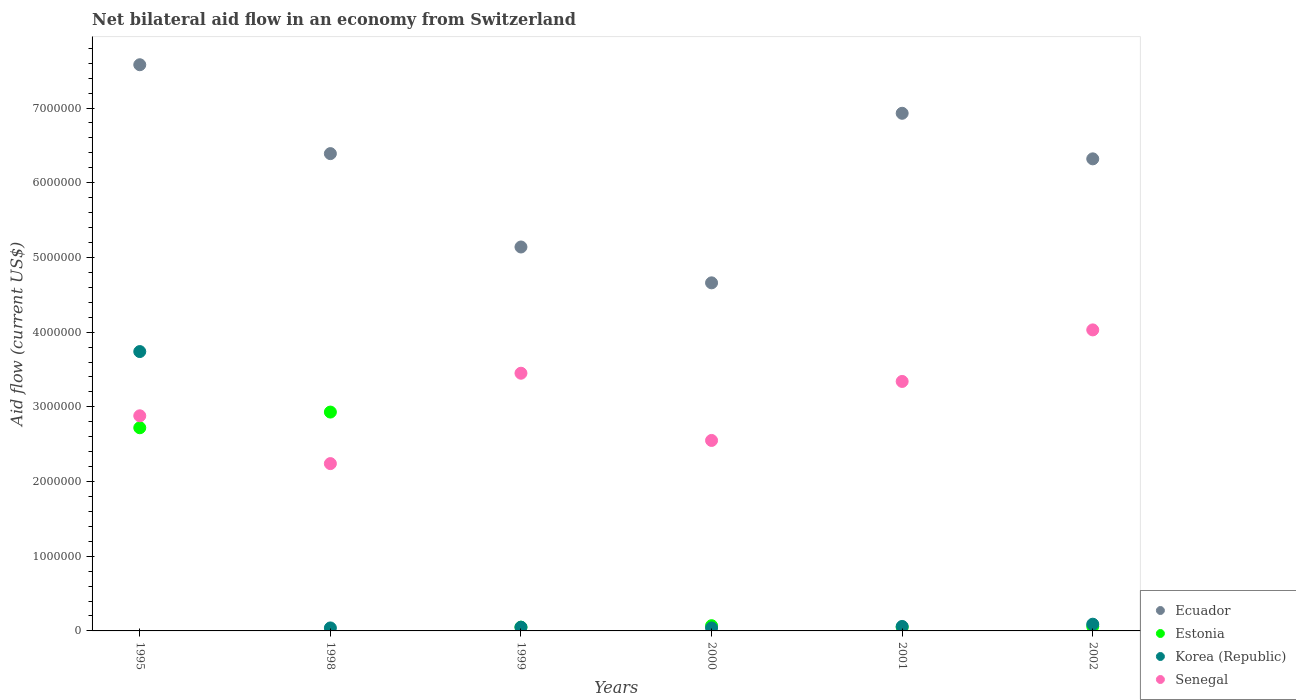How many different coloured dotlines are there?
Give a very brief answer. 4. Is the number of dotlines equal to the number of legend labels?
Offer a very short reply. Yes. What is the net bilateral aid flow in Korea (Republic) in 1995?
Your answer should be very brief. 3.74e+06. Across all years, what is the maximum net bilateral aid flow in Ecuador?
Provide a succinct answer. 7.58e+06. In which year was the net bilateral aid flow in Ecuador maximum?
Ensure brevity in your answer.  1995. What is the total net bilateral aid flow in Senegal in the graph?
Your response must be concise. 1.85e+07. What is the difference between the net bilateral aid flow in Ecuador in 1995 and that in 2002?
Offer a terse response. 1.26e+06. What is the difference between the net bilateral aid flow in Korea (Republic) in 1998 and the net bilateral aid flow in Senegal in 1995?
Keep it short and to the point. -2.84e+06. What is the average net bilateral aid flow in Estonia per year?
Your answer should be compact. 9.80e+05. In the year 1999, what is the difference between the net bilateral aid flow in Korea (Republic) and net bilateral aid flow in Ecuador?
Provide a succinct answer. -5.09e+06. In how many years, is the net bilateral aid flow in Estonia greater than 2600000 US$?
Your response must be concise. 2. What is the ratio of the net bilateral aid flow in Senegal in 1995 to that in 2000?
Make the answer very short. 1.13. Is the difference between the net bilateral aid flow in Korea (Republic) in 1995 and 2000 greater than the difference between the net bilateral aid flow in Ecuador in 1995 and 2000?
Offer a very short reply. Yes. What is the difference between the highest and the second highest net bilateral aid flow in Senegal?
Offer a terse response. 5.80e+05. What is the difference between the highest and the lowest net bilateral aid flow in Estonia?
Ensure brevity in your answer.  2.88e+06. In how many years, is the net bilateral aid flow in Korea (Republic) greater than the average net bilateral aid flow in Korea (Republic) taken over all years?
Your response must be concise. 1. Is the sum of the net bilateral aid flow in Estonia in 1995 and 2000 greater than the maximum net bilateral aid flow in Senegal across all years?
Keep it short and to the point. No. Does the net bilateral aid flow in Ecuador monotonically increase over the years?
Make the answer very short. No. Is the net bilateral aid flow in Senegal strictly greater than the net bilateral aid flow in Estonia over the years?
Provide a succinct answer. No. Is the net bilateral aid flow in Estonia strictly less than the net bilateral aid flow in Korea (Republic) over the years?
Your answer should be compact. No. How many years are there in the graph?
Ensure brevity in your answer.  6. Are the values on the major ticks of Y-axis written in scientific E-notation?
Your answer should be very brief. No. Does the graph contain any zero values?
Keep it short and to the point. No. How many legend labels are there?
Ensure brevity in your answer.  4. What is the title of the graph?
Your answer should be very brief. Net bilateral aid flow in an economy from Switzerland. What is the label or title of the Y-axis?
Keep it short and to the point. Aid flow (current US$). What is the Aid flow (current US$) of Ecuador in 1995?
Your answer should be compact. 7.58e+06. What is the Aid flow (current US$) in Estonia in 1995?
Your answer should be very brief. 2.72e+06. What is the Aid flow (current US$) in Korea (Republic) in 1995?
Your response must be concise. 3.74e+06. What is the Aid flow (current US$) in Senegal in 1995?
Your answer should be very brief. 2.88e+06. What is the Aid flow (current US$) of Ecuador in 1998?
Your response must be concise. 6.39e+06. What is the Aid flow (current US$) in Estonia in 1998?
Keep it short and to the point. 2.93e+06. What is the Aid flow (current US$) in Korea (Republic) in 1998?
Keep it short and to the point. 4.00e+04. What is the Aid flow (current US$) of Senegal in 1998?
Your response must be concise. 2.24e+06. What is the Aid flow (current US$) of Ecuador in 1999?
Your answer should be compact. 5.14e+06. What is the Aid flow (current US$) of Senegal in 1999?
Make the answer very short. 3.45e+06. What is the Aid flow (current US$) in Ecuador in 2000?
Keep it short and to the point. 4.66e+06. What is the Aid flow (current US$) of Korea (Republic) in 2000?
Your answer should be very brief. 4.00e+04. What is the Aid flow (current US$) of Senegal in 2000?
Offer a terse response. 2.55e+06. What is the Aid flow (current US$) in Ecuador in 2001?
Your answer should be compact. 6.93e+06. What is the Aid flow (current US$) in Estonia in 2001?
Offer a very short reply. 5.00e+04. What is the Aid flow (current US$) of Senegal in 2001?
Provide a short and direct response. 3.34e+06. What is the Aid flow (current US$) in Ecuador in 2002?
Provide a succinct answer. 6.32e+06. What is the Aid flow (current US$) in Estonia in 2002?
Offer a very short reply. 6.00e+04. What is the Aid flow (current US$) of Korea (Republic) in 2002?
Your answer should be compact. 9.00e+04. What is the Aid flow (current US$) in Senegal in 2002?
Offer a terse response. 4.03e+06. Across all years, what is the maximum Aid flow (current US$) in Ecuador?
Offer a terse response. 7.58e+06. Across all years, what is the maximum Aid flow (current US$) in Estonia?
Your response must be concise. 2.93e+06. Across all years, what is the maximum Aid flow (current US$) in Korea (Republic)?
Make the answer very short. 3.74e+06. Across all years, what is the maximum Aid flow (current US$) in Senegal?
Offer a very short reply. 4.03e+06. Across all years, what is the minimum Aid flow (current US$) of Ecuador?
Provide a succinct answer. 4.66e+06. Across all years, what is the minimum Aid flow (current US$) in Estonia?
Offer a terse response. 5.00e+04. Across all years, what is the minimum Aid flow (current US$) of Korea (Republic)?
Your answer should be very brief. 4.00e+04. Across all years, what is the minimum Aid flow (current US$) of Senegal?
Your answer should be compact. 2.24e+06. What is the total Aid flow (current US$) in Ecuador in the graph?
Provide a succinct answer. 3.70e+07. What is the total Aid flow (current US$) in Estonia in the graph?
Keep it short and to the point. 5.88e+06. What is the total Aid flow (current US$) of Korea (Republic) in the graph?
Your answer should be compact. 4.02e+06. What is the total Aid flow (current US$) in Senegal in the graph?
Ensure brevity in your answer.  1.85e+07. What is the difference between the Aid flow (current US$) in Ecuador in 1995 and that in 1998?
Offer a terse response. 1.19e+06. What is the difference between the Aid flow (current US$) of Estonia in 1995 and that in 1998?
Your answer should be very brief. -2.10e+05. What is the difference between the Aid flow (current US$) of Korea (Republic) in 1995 and that in 1998?
Provide a succinct answer. 3.70e+06. What is the difference between the Aid flow (current US$) of Senegal in 1995 and that in 1998?
Offer a very short reply. 6.40e+05. What is the difference between the Aid flow (current US$) of Ecuador in 1995 and that in 1999?
Offer a terse response. 2.44e+06. What is the difference between the Aid flow (current US$) in Estonia in 1995 and that in 1999?
Your answer should be compact. 2.67e+06. What is the difference between the Aid flow (current US$) of Korea (Republic) in 1995 and that in 1999?
Offer a very short reply. 3.69e+06. What is the difference between the Aid flow (current US$) in Senegal in 1995 and that in 1999?
Offer a terse response. -5.70e+05. What is the difference between the Aid flow (current US$) in Ecuador in 1995 and that in 2000?
Give a very brief answer. 2.92e+06. What is the difference between the Aid flow (current US$) in Estonia in 1995 and that in 2000?
Provide a succinct answer. 2.65e+06. What is the difference between the Aid flow (current US$) in Korea (Republic) in 1995 and that in 2000?
Keep it short and to the point. 3.70e+06. What is the difference between the Aid flow (current US$) in Senegal in 1995 and that in 2000?
Your response must be concise. 3.30e+05. What is the difference between the Aid flow (current US$) of Ecuador in 1995 and that in 2001?
Your answer should be compact. 6.50e+05. What is the difference between the Aid flow (current US$) of Estonia in 1995 and that in 2001?
Your answer should be compact. 2.67e+06. What is the difference between the Aid flow (current US$) of Korea (Republic) in 1995 and that in 2001?
Your answer should be very brief. 3.68e+06. What is the difference between the Aid flow (current US$) in Senegal in 1995 and that in 2001?
Your answer should be compact. -4.60e+05. What is the difference between the Aid flow (current US$) of Ecuador in 1995 and that in 2002?
Keep it short and to the point. 1.26e+06. What is the difference between the Aid flow (current US$) in Estonia in 1995 and that in 2002?
Ensure brevity in your answer.  2.66e+06. What is the difference between the Aid flow (current US$) in Korea (Republic) in 1995 and that in 2002?
Ensure brevity in your answer.  3.65e+06. What is the difference between the Aid flow (current US$) in Senegal in 1995 and that in 2002?
Offer a very short reply. -1.15e+06. What is the difference between the Aid flow (current US$) of Ecuador in 1998 and that in 1999?
Offer a terse response. 1.25e+06. What is the difference between the Aid flow (current US$) in Estonia in 1998 and that in 1999?
Provide a succinct answer. 2.88e+06. What is the difference between the Aid flow (current US$) in Senegal in 1998 and that in 1999?
Offer a very short reply. -1.21e+06. What is the difference between the Aid flow (current US$) in Ecuador in 1998 and that in 2000?
Make the answer very short. 1.73e+06. What is the difference between the Aid flow (current US$) of Estonia in 1998 and that in 2000?
Your response must be concise. 2.86e+06. What is the difference between the Aid flow (current US$) of Senegal in 1998 and that in 2000?
Offer a very short reply. -3.10e+05. What is the difference between the Aid flow (current US$) of Ecuador in 1998 and that in 2001?
Your response must be concise. -5.40e+05. What is the difference between the Aid flow (current US$) of Estonia in 1998 and that in 2001?
Offer a terse response. 2.88e+06. What is the difference between the Aid flow (current US$) in Senegal in 1998 and that in 2001?
Offer a terse response. -1.10e+06. What is the difference between the Aid flow (current US$) in Estonia in 1998 and that in 2002?
Offer a terse response. 2.87e+06. What is the difference between the Aid flow (current US$) in Korea (Republic) in 1998 and that in 2002?
Make the answer very short. -5.00e+04. What is the difference between the Aid flow (current US$) of Senegal in 1998 and that in 2002?
Give a very brief answer. -1.79e+06. What is the difference between the Aid flow (current US$) in Ecuador in 1999 and that in 2000?
Make the answer very short. 4.80e+05. What is the difference between the Aid flow (current US$) in Estonia in 1999 and that in 2000?
Keep it short and to the point. -2.00e+04. What is the difference between the Aid flow (current US$) of Senegal in 1999 and that in 2000?
Make the answer very short. 9.00e+05. What is the difference between the Aid flow (current US$) in Ecuador in 1999 and that in 2001?
Make the answer very short. -1.79e+06. What is the difference between the Aid flow (current US$) of Korea (Republic) in 1999 and that in 2001?
Your response must be concise. -10000. What is the difference between the Aid flow (current US$) in Ecuador in 1999 and that in 2002?
Offer a very short reply. -1.18e+06. What is the difference between the Aid flow (current US$) in Senegal in 1999 and that in 2002?
Your answer should be very brief. -5.80e+05. What is the difference between the Aid flow (current US$) in Ecuador in 2000 and that in 2001?
Offer a terse response. -2.27e+06. What is the difference between the Aid flow (current US$) in Korea (Republic) in 2000 and that in 2001?
Provide a succinct answer. -2.00e+04. What is the difference between the Aid flow (current US$) of Senegal in 2000 and that in 2001?
Offer a very short reply. -7.90e+05. What is the difference between the Aid flow (current US$) in Ecuador in 2000 and that in 2002?
Provide a short and direct response. -1.66e+06. What is the difference between the Aid flow (current US$) of Senegal in 2000 and that in 2002?
Your response must be concise. -1.48e+06. What is the difference between the Aid flow (current US$) of Ecuador in 2001 and that in 2002?
Ensure brevity in your answer.  6.10e+05. What is the difference between the Aid flow (current US$) in Estonia in 2001 and that in 2002?
Offer a terse response. -10000. What is the difference between the Aid flow (current US$) in Senegal in 2001 and that in 2002?
Your answer should be compact. -6.90e+05. What is the difference between the Aid flow (current US$) in Ecuador in 1995 and the Aid flow (current US$) in Estonia in 1998?
Your response must be concise. 4.65e+06. What is the difference between the Aid flow (current US$) of Ecuador in 1995 and the Aid flow (current US$) of Korea (Republic) in 1998?
Provide a succinct answer. 7.54e+06. What is the difference between the Aid flow (current US$) of Ecuador in 1995 and the Aid flow (current US$) of Senegal in 1998?
Provide a succinct answer. 5.34e+06. What is the difference between the Aid flow (current US$) in Estonia in 1995 and the Aid flow (current US$) in Korea (Republic) in 1998?
Provide a short and direct response. 2.68e+06. What is the difference between the Aid flow (current US$) in Estonia in 1995 and the Aid flow (current US$) in Senegal in 1998?
Provide a succinct answer. 4.80e+05. What is the difference between the Aid flow (current US$) of Korea (Republic) in 1995 and the Aid flow (current US$) of Senegal in 1998?
Your answer should be compact. 1.50e+06. What is the difference between the Aid flow (current US$) of Ecuador in 1995 and the Aid flow (current US$) of Estonia in 1999?
Provide a short and direct response. 7.53e+06. What is the difference between the Aid flow (current US$) in Ecuador in 1995 and the Aid flow (current US$) in Korea (Republic) in 1999?
Your answer should be very brief. 7.53e+06. What is the difference between the Aid flow (current US$) of Ecuador in 1995 and the Aid flow (current US$) of Senegal in 1999?
Offer a terse response. 4.13e+06. What is the difference between the Aid flow (current US$) of Estonia in 1995 and the Aid flow (current US$) of Korea (Republic) in 1999?
Your answer should be very brief. 2.67e+06. What is the difference between the Aid flow (current US$) of Estonia in 1995 and the Aid flow (current US$) of Senegal in 1999?
Offer a terse response. -7.30e+05. What is the difference between the Aid flow (current US$) of Korea (Republic) in 1995 and the Aid flow (current US$) of Senegal in 1999?
Provide a short and direct response. 2.90e+05. What is the difference between the Aid flow (current US$) of Ecuador in 1995 and the Aid flow (current US$) of Estonia in 2000?
Make the answer very short. 7.51e+06. What is the difference between the Aid flow (current US$) of Ecuador in 1995 and the Aid flow (current US$) of Korea (Republic) in 2000?
Ensure brevity in your answer.  7.54e+06. What is the difference between the Aid flow (current US$) in Ecuador in 1995 and the Aid flow (current US$) in Senegal in 2000?
Make the answer very short. 5.03e+06. What is the difference between the Aid flow (current US$) in Estonia in 1995 and the Aid flow (current US$) in Korea (Republic) in 2000?
Provide a succinct answer. 2.68e+06. What is the difference between the Aid flow (current US$) in Estonia in 1995 and the Aid flow (current US$) in Senegal in 2000?
Make the answer very short. 1.70e+05. What is the difference between the Aid flow (current US$) of Korea (Republic) in 1995 and the Aid flow (current US$) of Senegal in 2000?
Make the answer very short. 1.19e+06. What is the difference between the Aid flow (current US$) of Ecuador in 1995 and the Aid flow (current US$) of Estonia in 2001?
Provide a short and direct response. 7.53e+06. What is the difference between the Aid flow (current US$) in Ecuador in 1995 and the Aid flow (current US$) in Korea (Republic) in 2001?
Your answer should be very brief. 7.52e+06. What is the difference between the Aid flow (current US$) in Ecuador in 1995 and the Aid flow (current US$) in Senegal in 2001?
Keep it short and to the point. 4.24e+06. What is the difference between the Aid flow (current US$) of Estonia in 1995 and the Aid flow (current US$) of Korea (Republic) in 2001?
Your response must be concise. 2.66e+06. What is the difference between the Aid flow (current US$) in Estonia in 1995 and the Aid flow (current US$) in Senegal in 2001?
Your response must be concise. -6.20e+05. What is the difference between the Aid flow (current US$) in Ecuador in 1995 and the Aid flow (current US$) in Estonia in 2002?
Keep it short and to the point. 7.52e+06. What is the difference between the Aid flow (current US$) in Ecuador in 1995 and the Aid flow (current US$) in Korea (Republic) in 2002?
Offer a very short reply. 7.49e+06. What is the difference between the Aid flow (current US$) in Ecuador in 1995 and the Aid flow (current US$) in Senegal in 2002?
Your answer should be very brief. 3.55e+06. What is the difference between the Aid flow (current US$) in Estonia in 1995 and the Aid flow (current US$) in Korea (Republic) in 2002?
Your answer should be very brief. 2.63e+06. What is the difference between the Aid flow (current US$) in Estonia in 1995 and the Aid flow (current US$) in Senegal in 2002?
Offer a very short reply. -1.31e+06. What is the difference between the Aid flow (current US$) of Korea (Republic) in 1995 and the Aid flow (current US$) of Senegal in 2002?
Your answer should be compact. -2.90e+05. What is the difference between the Aid flow (current US$) of Ecuador in 1998 and the Aid flow (current US$) of Estonia in 1999?
Keep it short and to the point. 6.34e+06. What is the difference between the Aid flow (current US$) in Ecuador in 1998 and the Aid flow (current US$) in Korea (Republic) in 1999?
Provide a succinct answer. 6.34e+06. What is the difference between the Aid flow (current US$) in Ecuador in 1998 and the Aid flow (current US$) in Senegal in 1999?
Give a very brief answer. 2.94e+06. What is the difference between the Aid flow (current US$) of Estonia in 1998 and the Aid flow (current US$) of Korea (Republic) in 1999?
Ensure brevity in your answer.  2.88e+06. What is the difference between the Aid flow (current US$) in Estonia in 1998 and the Aid flow (current US$) in Senegal in 1999?
Your answer should be very brief. -5.20e+05. What is the difference between the Aid flow (current US$) in Korea (Republic) in 1998 and the Aid flow (current US$) in Senegal in 1999?
Your response must be concise. -3.41e+06. What is the difference between the Aid flow (current US$) in Ecuador in 1998 and the Aid flow (current US$) in Estonia in 2000?
Offer a terse response. 6.32e+06. What is the difference between the Aid flow (current US$) of Ecuador in 1998 and the Aid flow (current US$) of Korea (Republic) in 2000?
Your response must be concise. 6.35e+06. What is the difference between the Aid flow (current US$) in Ecuador in 1998 and the Aid flow (current US$) in Senegal in 2000?
Keep it short and to the point. 3.84e+06. What is the difference between the Aid flow (current US$) of Estonia in 1998 and the Aid flow (current US$) of Korea (Republic) in 2000?
Your response must be concise. 2.89e+06. What is the difference between the Aid flow (current US$) of Korea (Republic) in 1998 and the Aid flow (current US$) of Senegal in 2000?
Offer a terse response. -2.51e+06. What is the difference between the Aid flow (current US$) in Ecuador in 1998 and the Aid flow (current US$) in Estonia in 2001?
Offer a terse response. 6.34e+06. What is the difference between the Aid flow (current US$) in Ecuador in 1998 and the Aid flow (current US$) in Korea (Republic) in 2001?
Offer a very short reply. 6.33e+06. What is the difference between the Aid flow (current US$) of Ecuador in 1998 and the Aid flow (current US$) of Senegal in 2001?
Your answer should be very brief. 3.05e+06. What is the difference between the Aid flow (current US$) in Estonia in 1998 and the Aid flow (current US$) in Korea (Republic) in 2001?
Offer a terse response. 2.87e+06. What is the difference between the Aid flow (current US$) of Estonia in 1998 and the Aid flow (current US$) of Senegal in 2001?
Ensure brevity in your answer.  -4.10e+05. What is the difference between the Aid flow (current US$) of Korea (Republic) in 1998 and the Aid flow (current US$) of Senegal in 2001?
Your answer should be compact. -3.30e+06. What is the difference between the Aid flow (current US$) in Ecuador in 1998 and the Aid flow (current US$) in Estonia in 2002?
Your response must be concise. 6.33e+06. What is the difference between the Aid flow (current US$) in Ecuador in 1998 and the Aid flow (current US$) in Korea (Republic) in 2002?
Ensure brevity in your answer.  6.30e+06. What is the difference between the Aid flow (current US$) of Ecuador in 1998 and the Aid flow (current US$) of Senegal in 2002?
Provide a short and direct response. 2.36e+06. What is the difference between the Aid flow (current US$) of Estonia in 1998 and the Aid flow (current US$) of Korea (Republic) in 2002?
Give a very brief answer. 2.84e+06. What is the difference between the Aid flow (current US$) in Estonia in 1998 and the Aid flow (current US$) in Senegal in 2002?
Your answer should be compact. -1.10e+06. What is the difference between the Aid flow (current US$) in Korea (Republic) in 1998 and the Aid flow (current US$) in Senegal in 2002?
Offer a terse response. -3.99e+06. What is the difference between the Aid flow (current US$) of Ecuador in 1999 and the Aid flow (current US$) of Estonia in 2000?
Give a very brief answer. 5.07e+06. What is the difference between the Aid flow (current US$) in Ecuador in 1999 and the Aid flow (current US$) in Korea (Republic) in 2000?
Offer a very short reply. 5.10e+06. What is the difference between the Aid flow (current US$) of Ecuador in 1999 and the Aid flow (current US$) of Senegal in 2000?
Your response must be concise. 2.59e+06. What is the difference between the Aid flow (current US$) of Estonia in 1999 and the Aid flow (current US$) of Senegal in 2000?
Your response must be concise. -2.50e+06. What is the difference between the Aid flow (current US$) in Korea (Republic) in 1999 and the Aid flow (current US$) in Senegal in 2000?
Keep it short and to the point. -2.50e+06. What is the difference between the Aid flow (current US$) of Ecuador in 1999 and the Aid flow (current US$) of Estonia in 2001?
Offer a terse response. 5.09e+06. What is the difference between the Aid flow (current US$) in Ecuador in 1999 and the Aid flow (current US$) in Korea (Republic) in 2001?
Provide a succinct answer. 5.08e+06. What is the difference between the Aid flow (current US$) of Ecuador in 1999 and the Aid flow (current US$) of Senegal in 2001?
Your answer should be compact. 1.80e+06. What is the difference between the Aid flow (current US$) of Estonia in 1999 and the Aid flow (current US$) of Senegal in 2001?
Your answer should be very brief. -3.29e+06. What is the difference between the Aid flow (current US$) in Korea (Republic) in 1999 and the Aid flow (current US$) in Senegal in 2001?
Provide a short and direct response. -3.29e+06. What is the difference between the Aid flow (current US$) in Ecuador in 1999 and the Aid flow (current US$) in Estonia in 2002?
Your response must be concise. 5.08e+06. What is the difference between the Aid flow (current US$) in Ecuador in 1999 and the Aid flow (current US$) in Korea (Republic) in 2002?
Make the answer very short. 5.05e+06. What is the difference between the Aid flow (current US$) of Ecuador in 1999 and the Aid flow (current US$) of Senegal in 2002?
Provide a succinct answer. 1.11e+06. What is the difference between the Aid flow (current US$) in Estonia in 1999 and the Aid flow (current US$) in Senegal in 2002?
Provide a succinct answer. -3.98e+06. What is the difference between the Aid flow (current US$) of Korea (Republic) in 1999 and the Aid flow (current US$) of Senegal in 2002?
Provide a succinct answer. -3.98e+06. What is the difference between the Aid flow (current US$) of Ecuador in 2000 and the Aid flow (current US$) of Estonia in 2001?
Keep it short and to the point. 4.61e+06. What is the difference between the Aid flow (current US$) in Ecuador in 2000 and the Aid flow (current US$) in Korea (Republic) in 2001?
Give a very brief answer. 4.60e+06. What is the difference between the Aid flow (current US$) of Ecuador in 2000 and the Aid flow (current US$) of Senegal in 2001?
Provide a succinct answer. 1.32e+06. What is the difference between the Aid flow (current US$) in Estonia in 2000 and the Aid flow (current US$) in Senegal in 2001?
Your response must be concise. -3.27e+06. What is the difference between the Aid flow (current US$) in Korea (Republic) in 2000 and the Aid flow (current US$) in Senegal in 2001?
Keep it short and to the point. -3.30e+06. What is the difference between the Aid flow (current US$) of Ecuador in 2000 and the Aid flow (current US$) of Estonia in 2002?
Make the answer very short. 4.60e+06. What is the difference between the Aid flow (current US$) in Ecuador in 2000 and the Aid flow (current US$) in Korea (Republic) in 2002?
Provide a succinct answer. 4.57e+06. What is the difference between the Aid flow (current US$) of Ecuador in 2000 and the Aid flow (current US$) of Senegal in 2002?
Ensure brevity in your answer.  6.30e+05. What is the difference between the Aid flow (current US$) of Estonia in 2000 and the Aid flow (current US$) of Senegal in 2002?
Your answer should be compact. -3.96e+06. What is the difference between the Aid flow (current US$) of Korea (Republic) in 2000 and the Aid flow (current US$) of Senegal in 2002?
Make the answer very short. -3.99e+06. What is the difference between the Aid flow (current US$) of Ecuador in 2001 and the Aid flow (current US$) of Estonia in 2002?
Provide a short and direct response. 6.87e+06. What is the difference between the Aid flow (current US$) in Ecuador in 2001 and the Aid flow (current US$) in Korea (Republic) in 2002?
Keep it short and to the point. 6.84e+06. What is the difference between the Aid flow (current US$) in Ecuador in 2001 and the Aid flow (current US$) in Senegal in 2002?
Your response must be concise. 2.90e+06. What is the difference between the Aid flow (current US$) of Estonia in 2001 and the Aid flow (current US$) of Senegal in 2002?
Your answer should be very brief. -3.98e+06. What is the difference between the Aid flow (current US$) in Korea (Republic) in 2001 and the Aid flow (current US$) in Senegal in 2002?
Your answer should be compact. -3.97e+06. What is the average Aid flow (current US$) in Ecuador per year?
Provide a short and direct response. 6.17e+06. What is the average Aid flow (current US$) of Estonia per year?
Your response must be concise. 9.80e+05. What is the average Aid flow (current US$) of Korea (Republic) per year?
Keep it short and to the point. 6.70e+05. What is the average Aid flow (current US$) of Senegal per year?
Offer a terse response. 3.08e+06. In the year 1995, what is the difference between the Aid flow (current US$) of Ecuador and Aid flow (current US$) of Estonia?
Keep it short and to the point. 4.86e+06. In the year 1995, what is the difference between the Aid flow (current US$) in Ecuador and Aid flow (current US$) in Korea (Republic)?
Offer a terse response. 3.84e+06. In the year 1995, what is the difference between the Aid flow (current US$) of Ecuador and Aid flow (current US$) of Senegal?
Provide a short and direct response. 4.70e+06. In the year 1995, what is the difference between the Aid flow (current US$) of Estonia and Aid flow (current US$) of Korea (Republic)?
Keep it short and to the point. -1.02e+06. In the year 1995, what is the difference between the Aid flow (current US$) in Estonia and Aid flow (current US$) in Senegal?
Give a very brief answer. -1.60e+05. In the year 1995, what is the difference between the Aid flow (current US$) in Korea (Republic) and Aid flow (current US$) in Senegal?
Your answer should be very brief. 8.60e+05. In the year 1998, what is the difference between the Aid flow (current US$) in Ecuador and Aid flow (current US$) in Estonia?
Provide a succinct answer. 3.46e+06. In the year 1998, what is the difference between the Aid flow (current US$) of Ecuador and Aid flow (current US$) of Korea (Republic)?
Keep it short and to the point. 6.35e+06. In the year 1998, what is the difference between the Aid flow (current US$) of Ecuador and Aid flow (current US$) of Senegal?
Offer a very short reply. 4.15e+06. In the year 1998, what is the difference between the Aid flow (current US$) of Estonia and Aid flow (current US$) of Korea (Republic)?
Your response must be concise. 2.89e+06. In the year 1998, what is the difference between the Aid flow (current US$) in Estonia and Aid flow (current US$) in Senegal?
Give a very brief answer. 6.90e+05. In the year 1998, what is the difference between the Aid flow (current US$) of Korea (Republic) and Aid flow (current US$) of Senegal?
Offer a terse response. -2.20e+06. In the year 1999, what is the difference between the Aid flow (current US$) in Ecuador and Aid flow (current US$) in Estonia?
Offer a very short reply. 5.09e+06. In the year 1999, what is the difference between the Aid flow (current US$) in Ecuador and Aid flow (current US$) in Korea (Republic)?
Your response must be concise. 5.09e+06. In the year 1999, what is the difference between the Aid flow (current US$) in Ecuador and Aid flow (current US$) in Senegal?
Your response must be concise. 1.69e+06. In the year 1999, what is the difference between the Aid flow (current US$) of Estonia and Aid flow (current US$) of Senegal?
Your answer should be compact. -3.40e+06. In the year 1999, what is the difference between the Aid flow (current US$) in Korea (Republic) and Aid flow (current US$) in Senegal?
Give a very brief answer. -3.40e+06. In the year 2000, what is the difference between the Aid flow (current US$) in Ecuador and Aid flow (current US$) in Estonia?
Provide a short and direct response. 4.59e+06. In the year 2000, what is the difference between the Aid flow (current US$) in Ecuador and Aid flow (current US$) in Korea (Republic)?
Provide a succinct answer. 4.62e+06. In the year 2000, what is the difference between the Aid flow (current US$) in Ecuador and Aid flow (current US$) in Senegal?
Your answer should be compact. 2.11e+06. In the year 2000, what is the difference between the Aid flow (current US$) of Estonia and Aid flow (current US$) of Senegal?
Offer a terse response. -2.48e+06. In the year 2000, what is the difference between the Aid flow (current US$) in Korea (Republic) and Aid flow (current US$) in Senegal?
Make the answer very short. -2.51e+06. In the year 2001, what is the difference between the Aid flow (current US$) in Ecuador and Aid flow (current US$) in Estonia?
Keep it short and to the point. 6.88e+06. In the year 2001, what is the difference between the Aid flow (current US$) of Ecuador and Aid flow (current US$) of Korea (Republic)?
Your response must be concise. 6.87e+06. In the year 2001, what is the difference between the Aid flow (current US$) of Ecuador and Aid flow (current US$) of Senegal?
Keep it short and to the point. 3.59e+06. In the year 2001, what is the difference between the Aid flow (current US$) of Estonia and Aid flow (current US$) of Korea (Republic)?
Your answer should be very brief. -10000. In the year 2001, what is the difference between the Aid flow (current US$) in Estonia and Aid flow (current US$) in Senegal?
Give a very brief answer. -3.29e+06. In the year 2001, what is the difference between the Aid flow (current US$) in Korea (Republic) and Aid flow (current US$) in Senegal?
Keep it short and to the point. -3.28e+06. In the year 2002, what is the difference between the Aid flow (current US$) of Ecuador and Aid flow (current US$) of Estonia?
Your answer should be very brief. 6.26e+06. In the year 2002, what is the difference between the Aid flow (current US$) in Ecuador and Aid flow (current US$) in Korea (Republic)?
Offer a very short reply. 6.23e+06. In the year 2002, what is the difference between the Aid flow (current US$) in Ecuador and Aid flow (current US$) in Senegal?
Make the answer very short. 2.29e+06. In the year 2002, what is the difference between the Aid flow (current US$) of Estonia and Aid flow (current US$) of Korea (Republic)?
Offer a very short reply. -3.00e+04. In the year 2002, what is the difference between the Aid flow (current US$) of Estonia and Aid flow (current US$) of Senegal?
Your answer should be compact. -3.97e+06. In the year 2002, what is the difference between the Aid flow (current US$) in Korea (Republic) and Aid flow (current US$) in Senegal?
Provide a short and direct response. -3.94e+06. What is the ratio of the Aid flow (current US$) in Ecuador in 1995 to that in 1998?
Keep it short and to the point. 1.19. What is the ratio of the Aid flow (current US$) in Estonia in 1995 to that in 1998?
Offer a terse response. 0.93. What is the ratio of the Aid flow (current US$) in Korea (Republic) in 1995 to that in 1998?
Your answer should be very brief. 93.5. What is the ratio of the Aid flow (current US$) in Ecuador in 1995 to that in 1999?
Keep it short and to the point. 1.47. What is the ratio of the Aid flow (current US$) in Estonia in 1995 to that in 1999?
Keep it short and to the point. 54.4. What is the ratio of the Aid flow (current US$) in Korea (Republic) in 1995 to that in 1999?
Keep it short and to the point. 74.8. What is the ratio of the Aid flow (current US$) in Senegal in 1995 to that in 1999?
Your response must be concise. 0.83. What is the ratio of the Aid flow (current US$) of Ecuador in 1995 to that in 2000?
Make the answer very short. 1.63. What is the ratio of the Aid flow (current US$) in Estonia in 1995 to that in 2000?
Make the answer very short. 38.86. What is the ratio of the Aid flow (current US$) of Korea (Republic) in 1995 to that in 2000?
Keep it short and to the point. 93.5. What is the ratio of the Aid flow (current US$) of Senegal in 1995 to that in 2000?
Offer a very short reply. 1.13. What is the ratio of the Aid flow (current US$) in Ecuador in 1995 to that in 2001?
Ensure brevity in your answer.  1.09. What is the ratio of the Aid flow (current US$) of Estonia in 1995 to that in 2001?
Make the answer very short. 54.4. What is the ratio of the Aid flow (current US$) of Korea (Republic) in 1995 to that in 2001?
Provide a succinct answer. 62.33. What is the ratio of the Aid flow (current US$) of Senegal in 1995 to that in 2001?
Ensure brevity in your answer.  0.86. What is the ratio of the Aid flow (current US$) in Ecuador in 1995 to that in 2002?
Keep it short and to the point. 1.2. What is the ratio of the Aid flow (current US$) of Estonia in 1995 to that in 2002?
Offer a terse response. 45.33. What is the ratio of the Aid flow (current US$) of Korea (Republic) in 1995 to that in 2002?
Provide a short and direct response. 41.56. What is the ratio of the Aid flow (current US$) in Senegal in 1995 to that in 2002?
Your answer should be compact. 0.71. What is the ratio of the Aid flow (current US$) in Ecuador in 1998 to that in 1999?
Give a very brief answer. 1.24. What is the ratio of the Aid flow (current US$) of Estonia in 1998 to that in 1999?
Provide a short and direct response. 58.6. What is the ratio of the Aid flow (current US$) in Korea (Republic) in 1998 to that in 1999?
Provide a short and direct response. 0.8. What is the ratio of the Aid flow (current US$) of Senegal in 1998 to that in 1999?
Your answer should be very brief. 0.65. What is the ratio of the Aid flow (current US$) in Ecuador in 1998 to that in 2000?
Provide a short and direct response. 1.37. What is the ratio of the Aid flow (current US$) of Estonia in 1998 to that in 2000?
Make the answer very short. 41.86. What is the ratio of the Aid flow (current US$) in Korea (Republic) in 1998 to that in 2000?
Your answer should be compact. 1. What is the ratio of the Aid flow (current US$) of Senegal in 1998 to that in 2000?
Ensure brevity in your answer.  0.88. What is the ratio of the Aid flow (current US$) of Ecuador in 1998 to that in 2001?
Make the answer very short. 0.92. What is the ratio of the Aid flow (current US$) of Estonia in 1998 to that in 2001?
Your response must be concise. 58.6. What is the ratio of the Aid flow (current US$) in Korea (Republic) in 1998 to that in 2001?
Your answer should be compact. 0.67. What is the ratio of the Aid flow (current US$) in Senegal in 1998 to that in 2001?
Ensure brevity in your answer.  0.67. What is the ratio of the Aid flow (current US$) of Ecuador in 1998 to that in 2002?
Offer a terse response. 1.01. What is the ratio of the Aid flow (current US$) in Estonia in 1998 to that in 2002?
Your response must be concise. 48.83. What is the ratio of the Aid flow (current US$) of Korea (Republic) in 1998 to that in 2002?
Give a very brief answer. 0.44. What is the ratio of the Aid flow (current US$) of Senegal in 1998 to that in 2002?
Your answer should be very brief. 0.56. What is the ratio of the Aid flow (current US$) in Ecuador in 1999 to that in 2000?
Give a very brief answer. 1.1. What is the ratio of the Aid flow (current US$) of Estonia in 1999 to that in 2000?
Your response must be concise. 0.71. What is the ratio of the Aid flow (current US$) in Senegal in 1999 to that in 2000?
Give a very brief answer. 1.35. What is the ratio of the Aid flow (current US$) of Ecuador in 1999 to that in 2001?
Ensure brevity in your answer.  0.74. What is the ratio of the Aid flow (current US$) of Korea (Republic) in 1999 to that in 2001?
Provide a succinct answer. 0.83. What is the ratio of the Aid flow (current US$) in Senegal in 1999 to that in 2001?
Make the answer very short. 1.03. What is the ratio of the Aid flow (current US$) in Ecuador in 1999 to that in 2002?
Give a very brief answer. 0.81. What is the ratio of the Aid flow (current US$) in Korea (Republic) in 1999 to that in 2002?
Give a very brief answer. 0.56. What is the ratio of the Aid flow (current US$) in Senegal in 1999 to that in 2002?
Your response must be concise. 0.86. What is the ratio of the Aid flow (current US$) in Ecuador in 2000 to that in 2001?
Provide a succinct answer. 0.67. What is the ratio of the Aid flow (current US$) of Estonia in 2000 to that in 2001?
Offer a very short reply. 1.4. What is the ratio of the Aid flow (current US$) in Senegal in 2000 to that in 2001?
Provide a short and direct response. 0.76. What is the ratio of the Aid flow (current US$) of Ecuador in 2000 to that in 2002?
Make the answer very short. 0.74. What is the ratio of the Aid flow (current US$) of Korea (Republic) in 2000 to that in 2002?
Provide a succinct answer. 0.44. What is the ratio of the Aid flow (current US$) in Senegal in 2000 to that in 2002?
Your answer should be very brief. 0.63. What is the ratio of the Aid flow (current US$) of Ecuador in 2001 to that in 2002?
Provide a succinct answer. 1.1. What is the ratio of the Aid flow (current US$) in Estonia in 2001 to that in 2002?
Offer a terse response. 0.83. What is the ratio of the Aid flow (current US$) of Senegal in 2001 to that in 2002?
Your response must be concise. 0.83. What is the difference between the highest and the second highest Aid flow (current US$) in Ecuador?
Provide a succinct answer. 6.50e+05. What is the difference between the highest and the second highest Aid flow (current US$) of Estonia?
Keep it short and to the point. 2.10e+05. What is the difference between the highest and the second highest Aid flow (current US$) in Korea (Republic)?
Your answer should be very brief. 3.65e+06. What is the difference between the highest and the second highest Aid flow (current US$) of Senegal?
Your answer should be compact. 5.80e+05. What is the difference between the highest and the lowest Aid flow (current US$) in Ecuador?
Provide a succinct answer. 2.92e+06. What is the difference between the highest and the lowest Aid flow (current US$) in Estonia?
Offer a terse response. 2.88e+06. What is the difference between the highest and the lowest Aid flow (current US$) in Korea (Republic)?
Your answer should be compact. 3.70e+06. What is the difference between the highest and the lowest Aid flow (current US$) of Senegal?
Make the answer very short. 1.79e+06. 